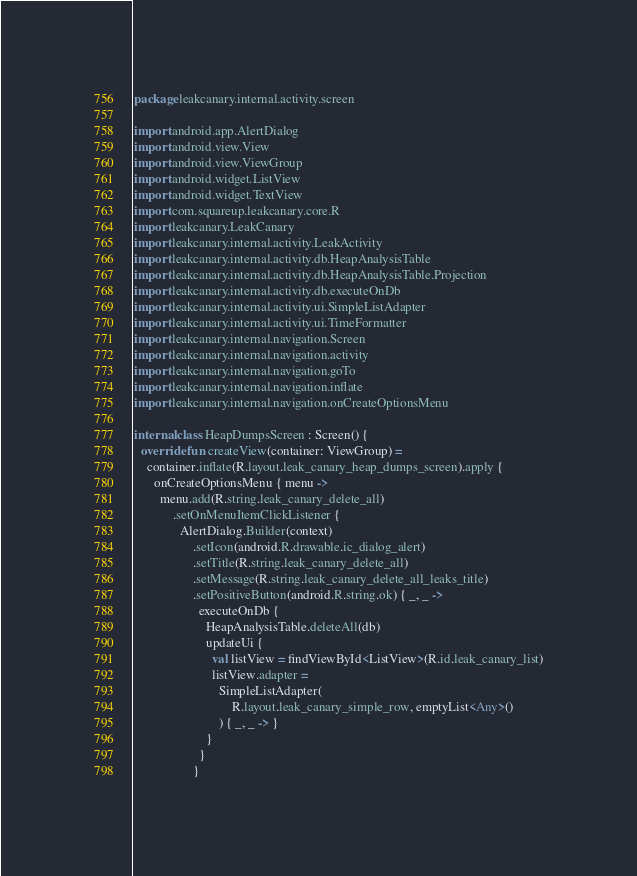Convert code to text. <code><loc_0><loc_0><loc_500><loc_500><_Kotlin_>package leakcanary.internal.activity.screen

import android.app.AlertDialog
import android.view.View
import android.view.ViewGroup
import android.widget.ListView
import android.widget.TextView
import com.squareup.leakcanary.core.R
import leakcanary.LeakCanary
import leakcanary.internal.activity.LeakActivity
import leakcanary.internal.activity.db.HeapAnalysisTable
import leakcanary.internal.activity.db.HeapAnalysisTable.Projection
import leakcanary.internal.activity.db.executeOnDb
import leakcanary.internal.activity.ui.SimpleListAdapter
import leakcanary.internal.activity.ui.TimeFormatter
import leakcanary.internal.navigation.Screen
import leakcanary.internal.navigation.activity
import leakcanary.internal.navigation.goTo
import leakcanary.internal.navigation.inflate
import leakcanary.internal.navigation.onCreateOptionsMenu

internal class HeapDumpsScreen : Screen() {
  override fun createView(container: ViewGroup) =
    container.inflate(R.layout.leak_canary_heap_dumps_screen).apply {
      onCreateOptionsMenu { menu ->
        menu.add(R.string.leak_canary_delete_all)
            .setOnMenuItemClickListener {
              AlertDialog.Builder(context)
                  .setIcon(android.R.drawable.ic_dialog_alert)
                  .setTitle(R.string.leak_canary_delete_all)
                  .setMessage(R.string.leak_canary_delete_all_leaks_title)
                  .setPositiveButton(android.R.string.ok) { _, _ ->
                    executeOnDb {
                      HeapAnalysisTable.deleteAll(db)
                      updateUi {
                        val listView = findViewById<ListView>(R.id.leak_canary_list)
                        listView.adapter =
                          SimpleListAdapter(
                              R.layout.leak_canary_simple_row, emptyList<Any>()
                          ) { _, _ -> }
                      }
                    }
                  }</code> 